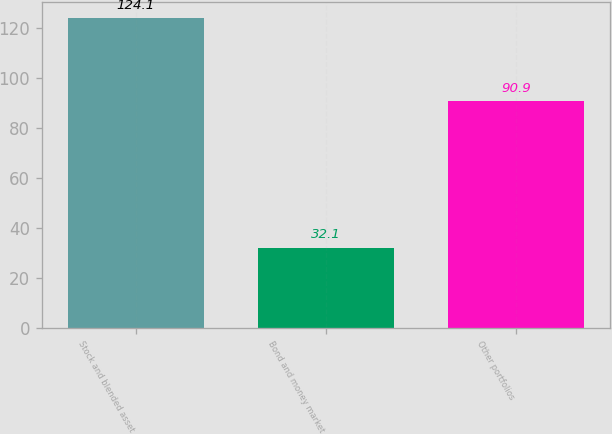<chart> <loc_0><loc_0><loc_500><loc_500><bar_chart><fcel>Stock and blended asset<fcel>Bond and money market<fcel>Other portfolios<nl><fcel>124.1<fcel>32.1<fcel>90.9<nl></chart> 